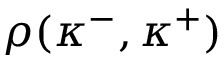<formula> <loc_0><loc_0><loc_500><loc_500>\rho ( \kappa ^ { - } , \kappa ^ { + } )</formula> 